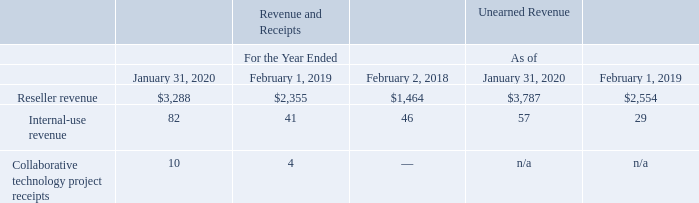Transactions with Dell
VMware and Dell engaged in the following ongoing related party transactions, which resulted in revenue and receipts, and unearned revenue for VMware:
• Pursuant to OEM and reseller arrangements, Dell integrates or bundles VMware’s products and services with Dell’s products and sells them to end users. Dell also acts as a distributor, purchasing VMware’s standalone products and services for resale to end-user customers through VMwareauthorized resellers. Revenue under these arrangements is presented net of related marketing development funds and rebates paid to Dell. In addition, VMware provides professional services to end users based upon contractual agreements with Dell. • Dell purchases products and services from VMware for its internal use. • From time to time, VMware and Dell enter into agreements to collaborate on technology projects, and Dell pays VMware for services or reimburses VMware for costs incurred by VMware, in connection with such projects.
Dell purchases VMware products and services directly from VMware, as well as through VMware’s channel partners. Information about VMware’s
revenue and receipts, and unearned revenue from such arrangements, for the periods presented consisted of the following (table in millions):
Customer deposits resulting from transactions with Dell were $194 million and $85 million as of January 31, 2020 and February 1, 2019, respectively
What were the customer deposits resulting from transactions with Dell in 2020? $194 million. What was the unearned reseller revenue as of 2019?
Answer scale should be: million. 2,554. What was the Collaborative technology project receipts revenue in 2019? 
Answer scale should be: million. 4. What was the change in reseller revenue between 2018 and 2019?
Answer scale should be: million. 2,355-1,464
Answer: 891. How many years did unearned Internal-use revenue exceed $30 million? 2020
Answer: 1. What was the percentage change in the Collaborative technology project receipts revenue between 2019 and 2020?
Answer scale should be: percent. (10-4)/4
Answer: 150. 